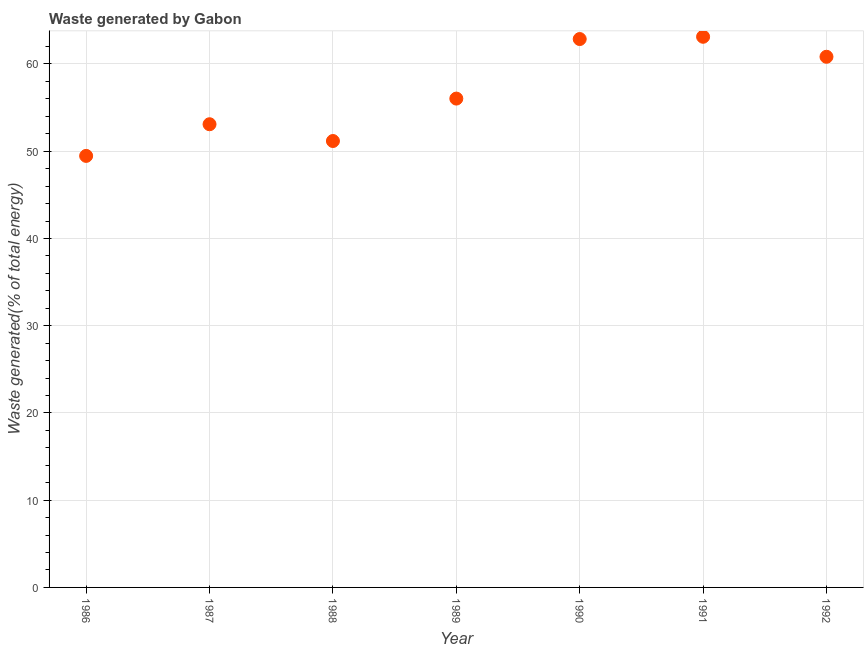What is the amount of waste generated in 1986?
Make the answer very short. 49.46. Across all years, what is the maximum amount of waste generated?
Make the answer very short. 63.12. Across all years, what is the minimum amount of waste generated?
Offer a very short reply. 49.46. What is the sum of the amount of waste generated?
Offer a terse response. 396.55. What is the difference between the amount of waste generated in 1987 and 1992?
Make the answer very short. -7.73. What is the average amount of waste generated per year?
Your response must be concise. 56.65. What is the median amount of waste generated?
Your answer should be very brief. 56.03. What is the ratio of the amount of waste generated in 1987 to that in 1988?
Make the answer very short. 1.04. Is the difference between the amount of waste generated in 1987 and 1992 greater than the difference between any two years?
Keep it short and to the point. No. What is the difference between the highest and the second highest amount of waste generated?
Offer a terse response. 0.26. What is the difference between the highest and the lowest amount of waste generated?
Offer a terse response. 13.65. In how many years, is the amount of waste generated greater than the average amount of waste generated taken over all years?
Provide a succinct answer. 3. Does the amount of waste generated monotonically increase over the years?
Your answer should be compact. No. How many dotlines are there?
Offer a very short reply. 1. How many years are there in the graph?
Ensure brevity in your answer.  7. Does the graph contain any zero values?
Provide a short and direct response. No. Does the graph contain grids?
Ensure brevity in your answer.  Yes. What is the title of the graph?
Offer a very short reply. Waste generated by Gabon. What is the label or title of the Y-axis?
Your answer should be very brief. Waste generated(% of total energy). What is the Waste generated(% of total energy) in 1986?
Keep it short and to the point. 49.46. What is the Waste generated(% of total energy) in 1987?
Give a very brief answer. 53.09. What is the Waste generated(% of total energy) in 1988?
Offer a very short reply. 51.17. What is the Waste generated(% of total energy) in 1989?
Provide a short and direct response. 56.03. What is the Waste generated(% of total energy) in 1990?
Provide a short and direct response. 62.86. What is the Waste generated(% of total energy) in 1991?
Offer a very short reply. 63.12. What is the Waste generated(% of total energy) in 1992?
Give a very brief answer. 60.83. What is the difference between the Waste generated(% of total energy) in 1986 and 1987?
Make the answer very short. -3.63. What is the difference between the Waste generated(% of total energy) in 1986 and 1988?
Your answer should be compact. -1.71. What is the difference between the Waste generated(% of total energy) in 1986 and 1989?
Your response must be concise. -6.57. What is the difference between the Waste generated(% of total energy) in 1986 and 1990?
Ensure brevity in your answer.  -13.39. What is the difference between the Waste generated(% of total energy) in 1986 and 1991?
Make the answer very short. -13.65. What is the difference between the Waste generated(% of total energy) in 1986 and 1992?
Keep it short and to the point. -11.36. What is the difference between the Waste generated(% of total energy) in 1987 and 1988?
Make the answer very short. 1.92. What is the difference between the Waste generated(% of total energy) in 1987 and 1989?
Your answer should be very brief. -2.94. What is the difference between the Waste generated(% of total energy) in 1987 and 1990?
Offer a very short reply. -9.77. What is the difference between the Waste generated(% of total energy) in 1987 and 1991?
Make the answer very short. -10.02. What is the difference between the Waste generated(% of total energy) in 1987 and 1992?
Provide a short and direct response. -7.73. What is the difference between the Waste generated(% of total energy) in 1988 and 1989?
Keep it short and to the point. -4.86. What is the difference between the Waste generated(% of total energy) in 1988 and 1990?
Offer a terse response. -11.69. What is the difference between the Waste generated(% of total energy) in 1988 and 1991?
Offer a very short reply. -11.95. What is the difference between the Waste generated(% of total energy) in 1988 and 1992?
Offer a terse response. -9.66. What is the difference between the Waste generated(% of total energy) in 1989 and 1990?
Your response must be concise. -6.82. What is the difference between the Waste generated(% of total energy) in 1989 and 1991?
Give a very brief answer. -7.08. What is the difference between the Waste generated(% of total energy) in 1989 and 1992?
Keep it short and to the point. -4.79. What is the difference between the Waste generated(% of total energy) in 1990 and 1991?
Provide a short and direct response. -0.26. What is the difference between the Waste generated(% of total energy) in 1990 and 1992?
Make the answer very short. 2.03. What is the difference between the Waste generated(% of total energy) in 1991 and 1992?
Provide a succinct answer. 2.29. What is the ratio of the Waste generated(% of total energy) in 1986 to that in 1987?
Keep it short and to the point. 0.93. What is the ratio of the Waste generated(% of total energy) in 1986 to that in 1988?
Your response must be concise. 0.97. What is the ratio of the Waste generated(% of total energy) in 1986 to that in 1989?
Keep it short and to the point. 0.88. What is the ratio of the Waste generated(% of total energy) in 1986 to that in 1990?
Give a very brief answer. 0.79. What is the ratio of the Waste generated(% of total energy) in 1986 to that in 1991?
Offer a very short reply. 0.78. What is the ratio of the Waste generated(% of total energy) in 1986 to that in 1992?
Offer a terse response. 0.81. What is the ratio of the Waste generated(% of total energy) in 1987 to that in 1988?
Give a very brief answer. 1.04. What is the ratio of the Waste generated(% of total energy) in 1987 to that in 1989?
Offer a very short reply. 0.95. What is the ratio of the Waste generated(% of total energy) in 1987 to that in 1990?
Your answer should be compact. 0.84. What is the ratio of the Waste generated(% of total energy) in 1987 to that in 1991?
Your response must be concise. 0.84. What is the ratio of the Waste generated(% of total energy) in 1987 to that in 1992?
Ensure brevity in your answer.  0.87. What is the ratio of the Waste generated(% of total energy) in 1988 to that in 1990?
Provide a short and direct response. 0.81. What is the ratio of the Waste generated(% of total energy) in 1988 to that in 1991?
Give a very brief answer. 0.81. What is the ratio of the Waste generated(% of total energy) in 1988 to that in 1992?
Ensure brevity in your answer.  0.84. What is the ratio of the Waste generated(% of total energy) in 1989 to that in 1990?
Give a very brief answer. 0.89. What is the ratio of the Waste generated(% of total energy) in 1989 to that in 1991?
Your response must be concise. 0.89. What is the ratio of the Waste generated(% of total energy) in 1989 to that in 1992?
Your response must be concise. 0.92. What is the ratio of the Waste generated(% of total energy) in 1990 to that in 1991?
Give a very brief answer. 1. What is the ratio of the Waste generated(% of total energy) in 1990 to that in 1992?
Offer a terse response. 1.03. What is the ratio of the Waste generated(% of total energy) in 1991 to that in 1992?
Give a very brief answer. 1.04. 